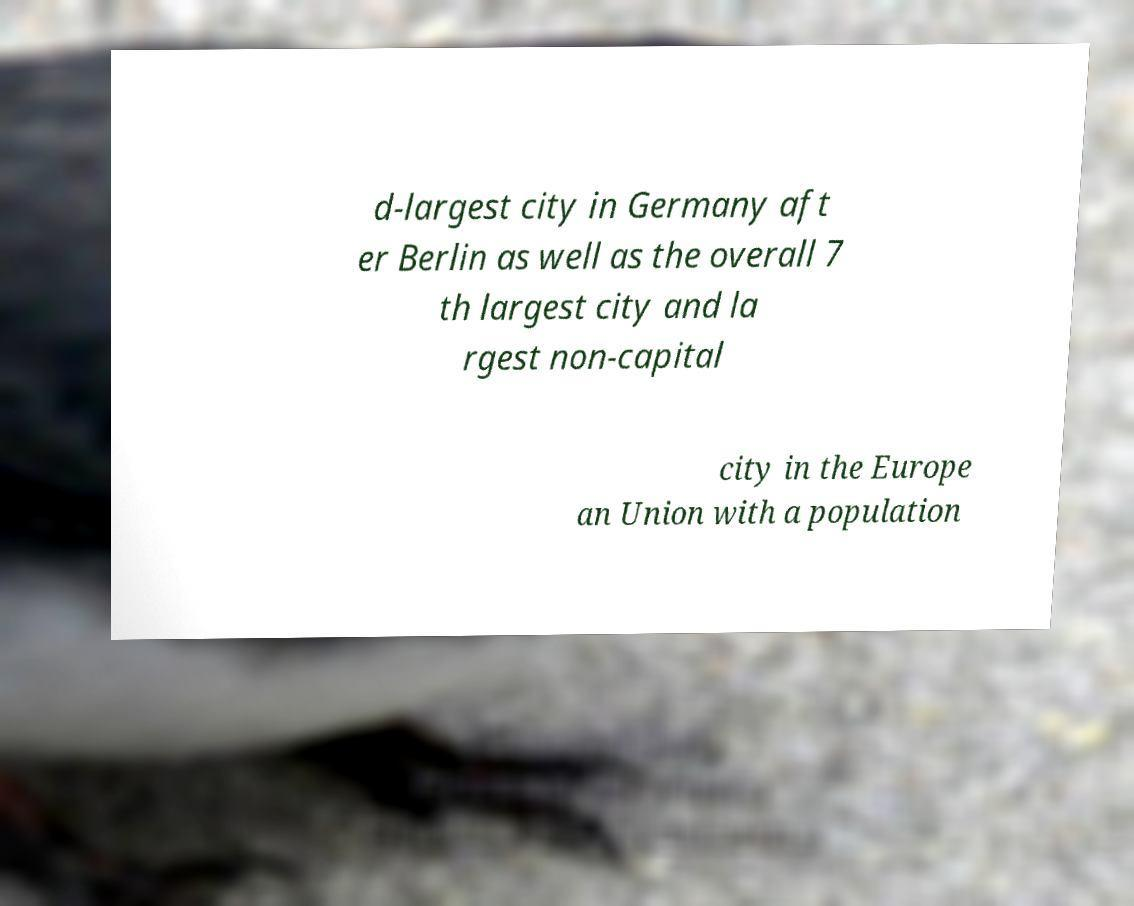Can you read and provide the text displayed in the image?This photo seems to have some interesting text. Can you extract and type it out for me? d-largest city in Germany aft er Berlin as well as the overall 7 th largest city and la rgest non-capital city in the Europe an Union with a population 